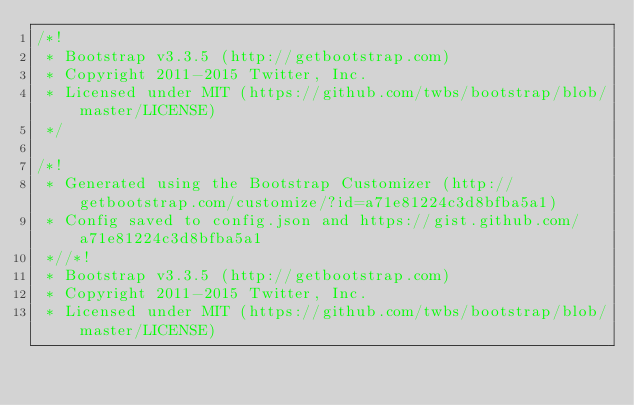Convert code to text. <code><loc_0><loc_0><loc_500><loc_500><_CSS_>/*!
 * Bootstrap v3.3.5 (http://getbootstrap.com)
 * Copyright 2011-2015 Twitter, Inc.
 * Licensed under MIT (https://github.com/twbs/bootstrap/blob/master/LICENSE)
 */

/*!
 * Generated using the Bootstrap Customizer (http://getbootstrap.com/customize/?id=a71e81224c3d8bfba5a1)
 * Config saved to config.json and https://gist.github.com/a71e81224c3d8bfba5a1
 *//*!
 * Bootstrap v3.3.5 (http://getbootstrap.com)
 * Copyright 2011-2015 Twitter, Inc.
 * Licensed under MIT (https://github.com/twbs/bootstrap/blob/master/LICENSE)</code> 